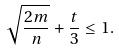Convert formula to latex. <formula><loc_0><loc_0><loc_500><loc_500>\sqrt { \frac { 2 m } { n } } + \frac { t } { 3 } \leq 1 .</formula> 